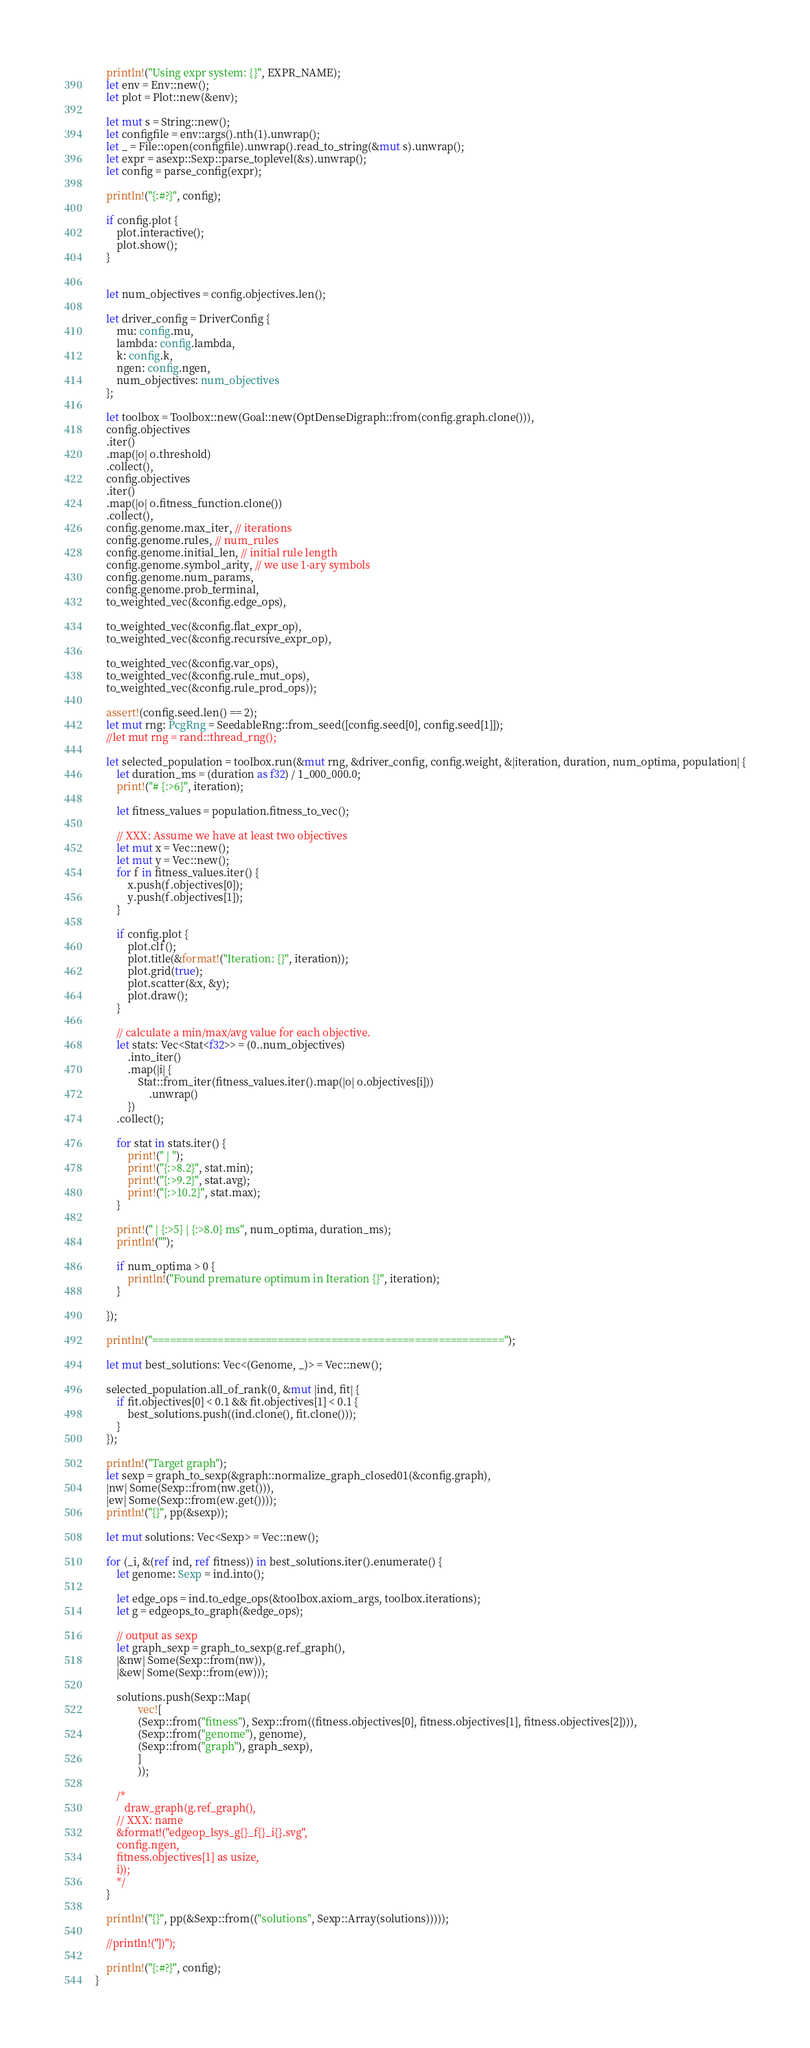Convert code to text. <code><loc_0><loc_0><loc_500><loc_500><_Rust_>    println!("Using expr system: {}", EXPR_NAME);
    let env = Env::new();
    let plot = Plot::new(&env);

    let mut s = String::new();
    let configfile = env::args().nth(1).unwrap();
    let _ = File::open(configfile).unwrap().read_to_string(&mut s).unwrap();
    let expr = asexp::Sexp::parse_toplevel(&s).unwrap();
    let config = parse_config(expr);

    println!("{:#?}", config);

    if config.plot {
        plot.interactive();
        plot.show();
    }


    let num_objectives = config.objectives.len();

    let driver_config = DriverConfig {
        mu: config.mu,
        lambda: config.lambda,
        k: config.k,
        ngen: config.ngen,
        num_objectives: num_objectives
    };

    let toolbox = Toolbox::new(Goal::new(OptDenseDigraph::from(config.graph.clone())),
    config.objectives
    .iter()
    .map(|o| o.threshold)
    .collect(),
    config.objectives
    .iter()
    .map(|o| o.fitness_function.clone())
    .collect(),
    config.genome.max_iter, // iterations
    config.genome.rules, // num_rules
    config.genome.initial_len, // initial rule length
    config.genome.symbol_arity, // we use 1-ary symbols
    config.genome.num_params,
    config.genome.prob_terminal,
    to_weighted_vec(&config.edge_ops),

    to_weighted_vec(&config.flat_expr_op),
    to_weighted_vec(&config.recursive_expr_op),

    to_weighted_vec(&config.var_ops),
    to_weighted_vec(&config.rule_mut_ops),
    to_weighted_vec(&config.rule_prod_ops));

    assert!(config.seed.len() == 2);
    let mut rng: PcgRng = SeedableRng::from_seed([config.seed[0], config.seed[1]]);
    //let mut rng = rand::thread_rng();

    let selected_population = toolbox.run(&mut rng, &driver_config, config.weight, &|iteration, duration, num_optima, population| {
        let duration_ms = (duration as f32) / 1_000_000.0;
        print!("# {:>6}", iteration);

        let fitness_values = population.fitness_to_vec();

        // XXX: Assume we have at least two objectives
        let mut x = Vec::new();
        let mut y = Vec::new();
        for f in fitness_values.iter() {
            x.push(f.objectives[0]);
            y.push(f.objectives[1]);
        }

        if config.plot {
            plot.clf();
            plot.title(&format!("Iteration: {}", iteration));
            plot.grid(true);
            plot.scatter(&x, &y);
            plot.draw();
        }

        // calculate a min/max/avg value for each objective.
        let stats: Vec<Stat<f32>> = (0..num_objectives)
            .into_iter()
            .map(|i| {
                Stat::from_iter(fitness_values.iter().map(|o| o.objectives[i]))
                    .unwrap()
            })
        .collect();

        for stat in stats.iter() {
            print!(" | ");
            print!("{:>8.2}", stat.min);
            print!("{:>9.2}", stat.avg);
            print!("{:>10.2}", stat.max);
        }

        print!(" | {:>5} | {:>8.0} ms", num_optima, duration_ms);
        println!("");

        if num_optima > 0 {
            println!("Found premature optimum in Iteration {}", iteration);
        }

    });

    println!("===========================================================");

    let mut best_solutions: Vec<(Genome, _)> = Vec::new();

    selected_population.all_of_rank(0, &mut |ind, fit| {
        if fit.objectives[0] < 0.1 && fit.objectives[1] < 0.1 {
            best_solutions.push((ind.clone(), fit.clone()));
        }
    });

    println!("Target graph");
    let sexp = graph_to_sexp(&graph::normalize_graph_closed01(&config.graph),
    |nw| Some(Sexp::from(nw.get())),
    |ew| Some(Sexp::from(ew.get())));
    println!("{}", pp(&sexp));

    let mut solutions: Vec<Sexp> = Vec::new();

    for (_i, &(ref ind, ref fitness)) in best_solutions.iter().enumerate() {
        let genome: Sexp = ind.into();

        let edge_ops = ind.to_edge_ops(&toolbox.axiom_args, toolbox.iterations);
        let g = edgeops_to_graph(&edge_ops);

        // output as sexp
        let graph_sexp = graph_to_sexp(g.ref_graph(),
        |&nw| Some(Sexp::from(nw)),
        |&ew| Some(Sexp::from(ew)));

        solutions.push(Sexp::Map(
                vec![
                (Sexp::from("fitness"), Sexp::from((fitness.objectives[0], fitness.objectives[1], fitness.objectives[2]))),
                (Sexp::from("genome"), genome),
                (Sexp::from("graph"), graph_sexp),
                ]
                ));

        /*
           draw_graph(g.ref_graph(),
        // XXX: name
        &format!("edgeop_lsys_g{}_f{}_i{}.svg",
        config.ngen,
        fitness.objectives[1] as usize,
        i));
        */
    }

    println!("{}", pp(&Sexp::from(("solutions", Sexp::Array(solutions)))));

    //println!("])");

    println!("{:#?}", config);
}
</code> 